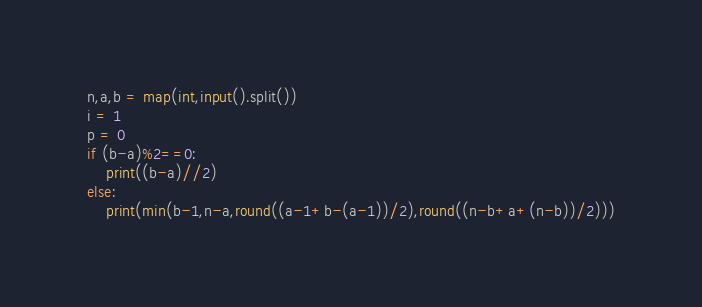Convert code to text. <code><loc_0><loc_0><loc_500><loc_500><_Python_>n,a,b = map(int,input().split())
i = 1
p = 0
if (b-a)%2==0:
    print((b-a)//2)
else:
    print(min(b-1,n-a,round((a-1+b-(a-1))/2),round((n-b+a+(n-b))/2)))</code> 